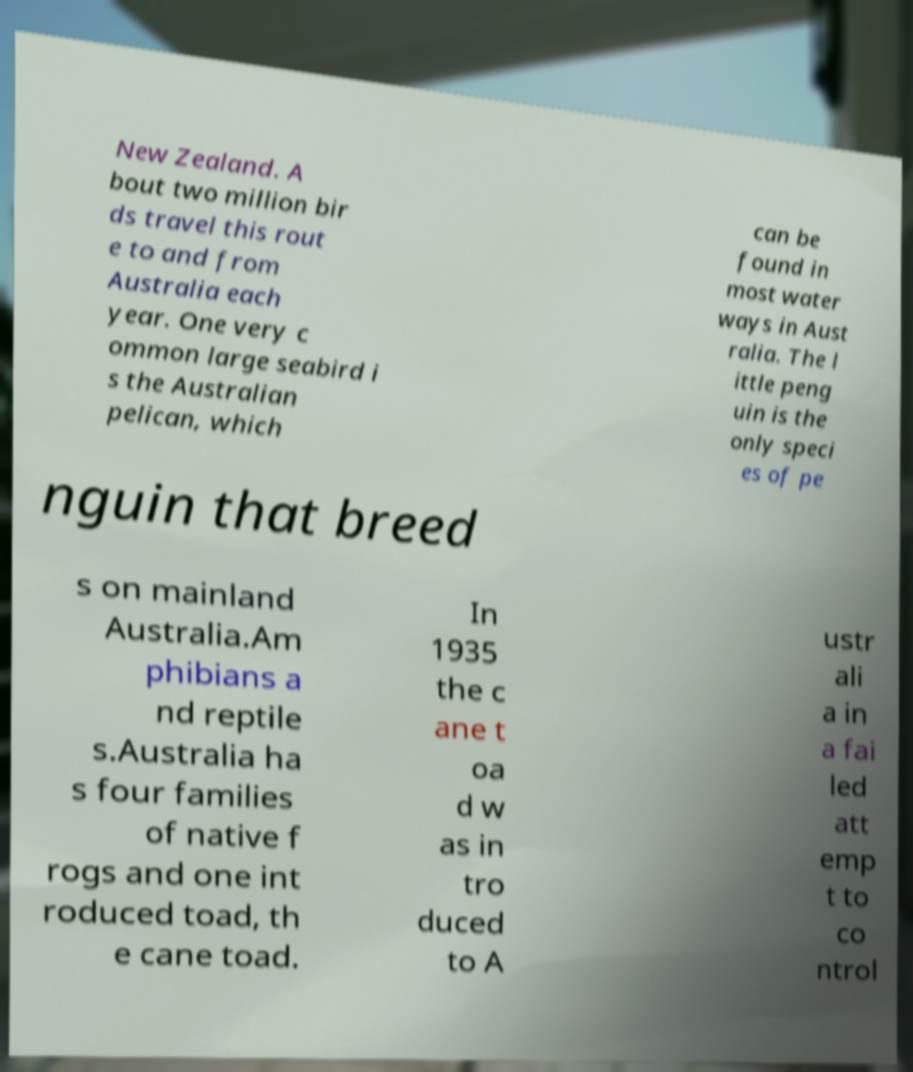Could you extract and type out the text from this image? New Zealand. A bout two million bir ds travel this rout e to and from Australia each year. One very c ommon large seabird i s the Australian pelican, which can be found in most water ways in Aust ralia. The l ittle peng uin is the only speci es of pe nguin that breed s on mainland Australia.Am phibians a nd reptile s.Australia ha s four families of native f rogs and one int roduced toad, th e cane toad. In 1935 the c ane t oa d w as in tro duced to A ustr ali a in a fai led att emp t to co ntrol 